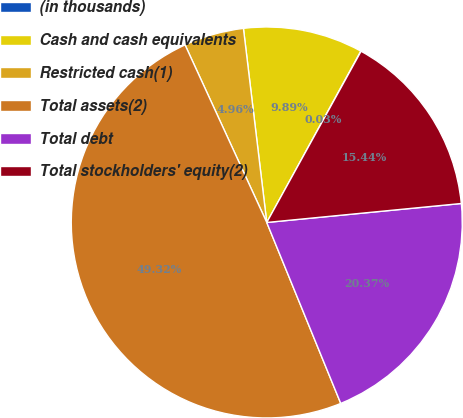<chart> <loc_0><loc_0><loc_500><loc_500><pie_chart><fcel>(in thousands)<fcel>Cash and cash equivalents<fcel>Restricted cash(1)<fcel>Total assets(2)<fcel>Total debt<fcel>Total stockholders' equity(2)<nl><fcel>0.03%<fcel>9.89%<fcel>4.96%<fcel>49.32%<fcel>20.37%<fcel>15.44%<nl></chart> 